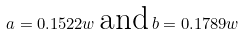<formula> <loc_0><loc_0><loc_500><loc_500>a = 0 . 1 5 2 2 w \, \text {and} \, b = 0 . 1 7 8 9 w</formula> 